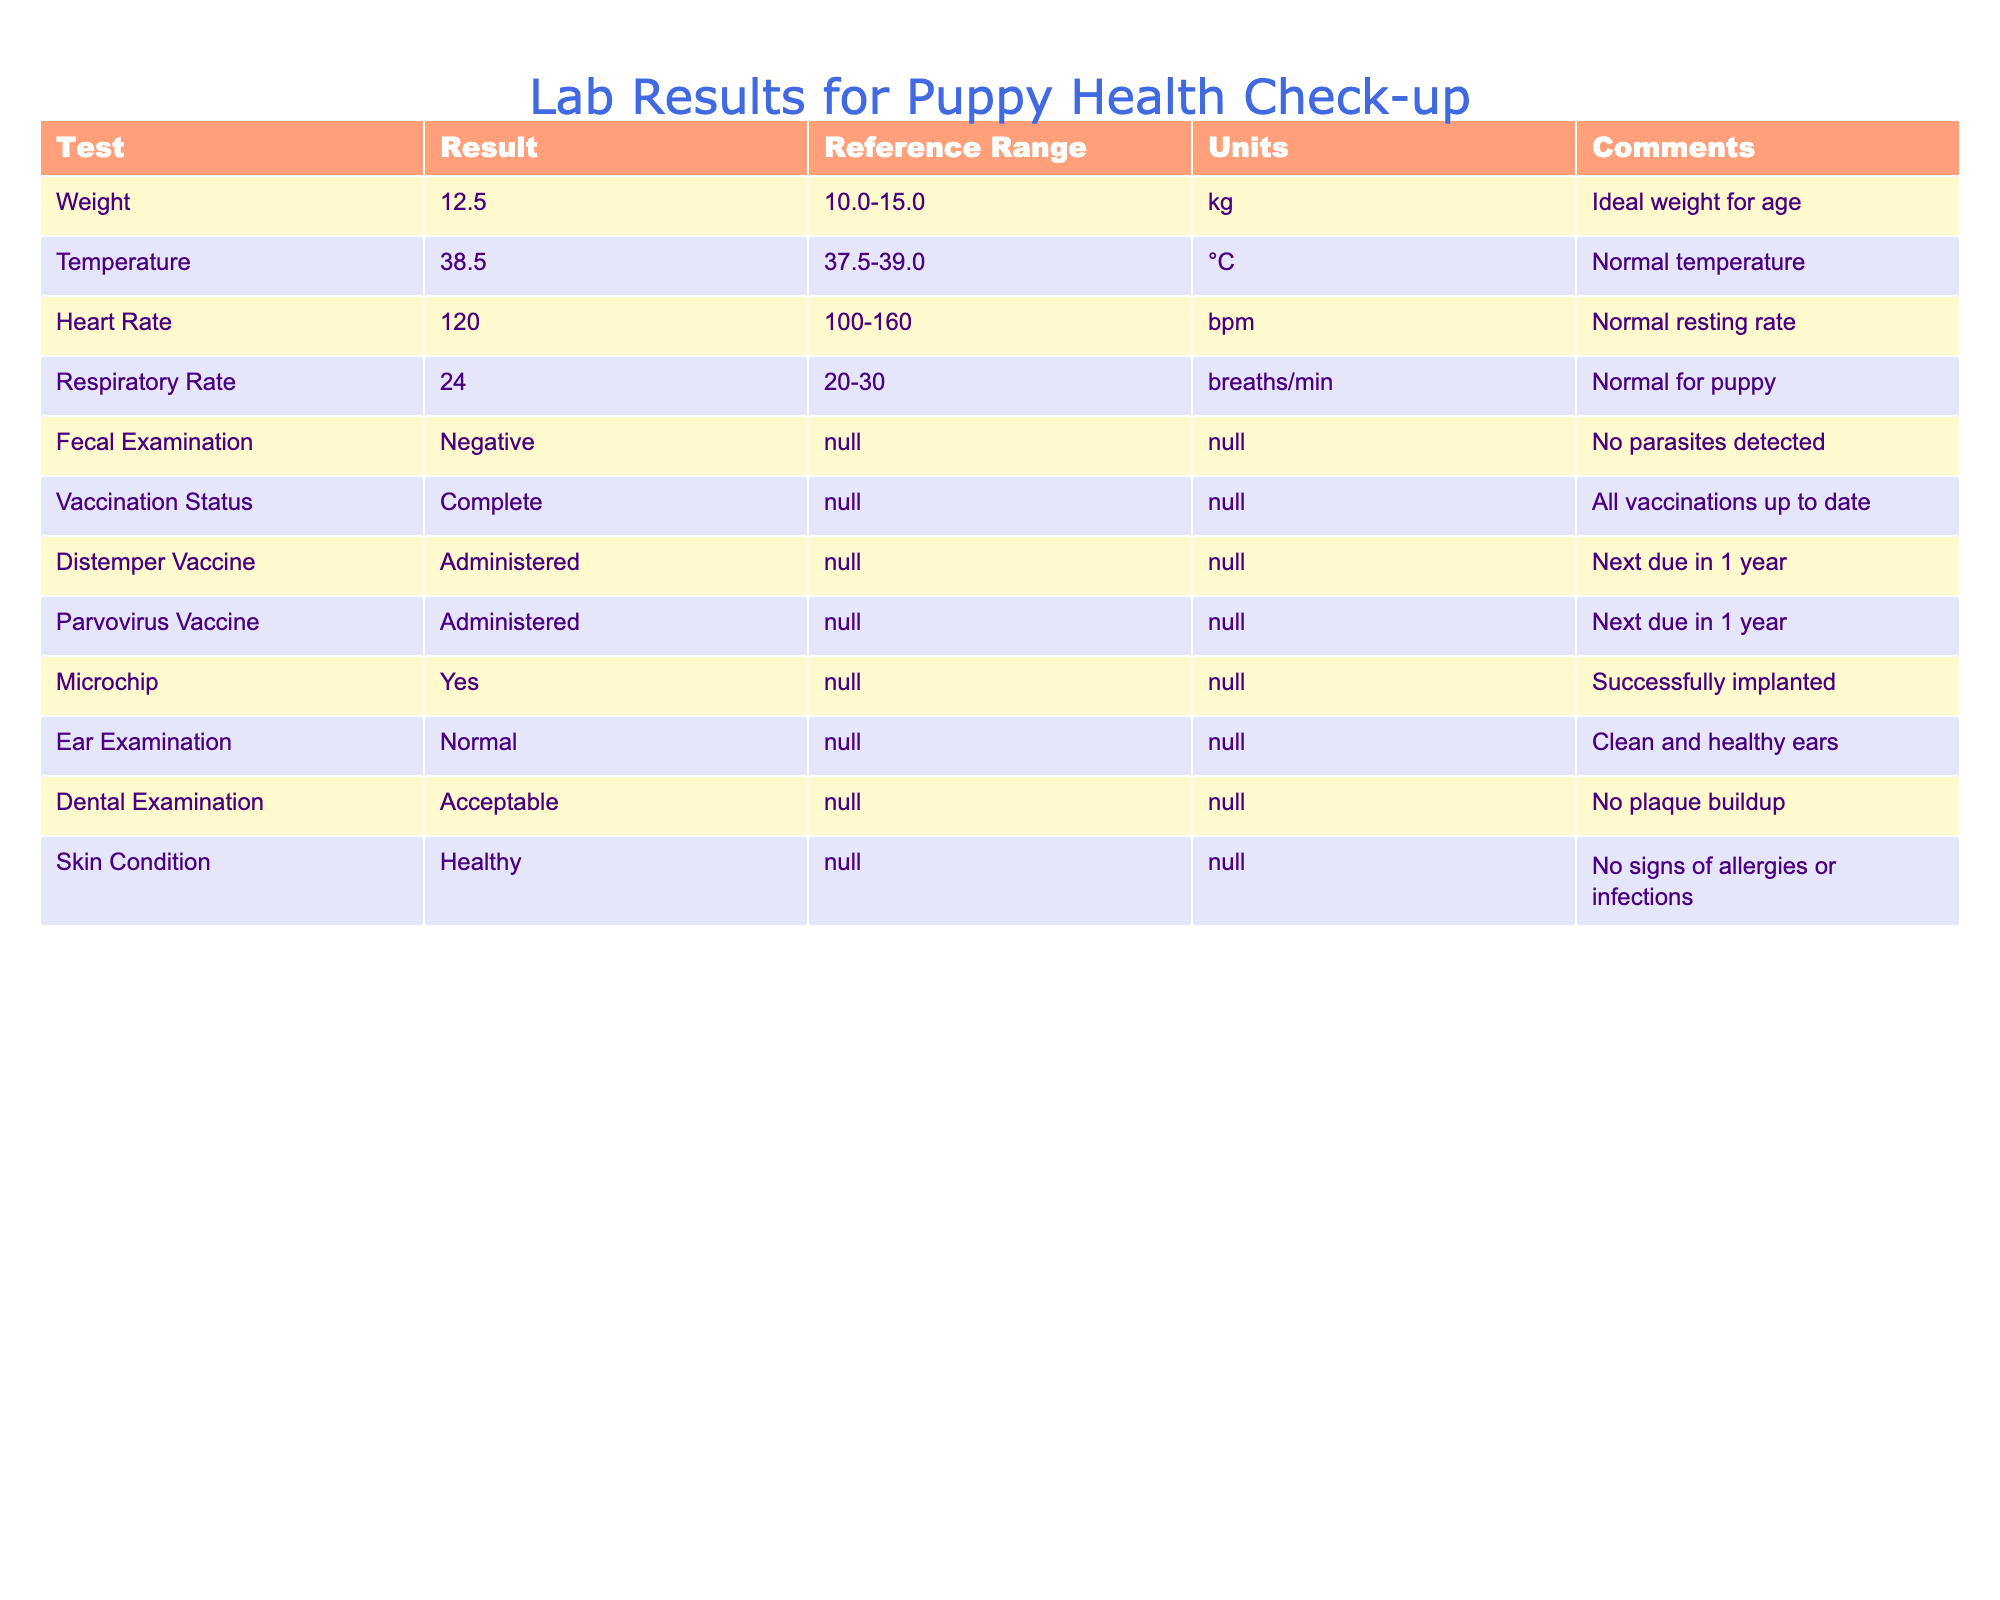What is the puppy's weight? The table lists the "Weight" under the test column, which shows a result of 12.5 kg.
Answer: 12.5 kg Is the puppy's temperature within the normal range? The reference range for temperature is 37.5-39.0 °C, and the puppy's temperature is recorded as 38.5 °C, which is within this range.
Answer: Yes What is the puppy's heart rate? The heart rate is listed under the test column, with a value of 120 bpm.
Answer: 120 bpm How many vaccines has the puppy received? The table contains two rows regarding vaccines: Distemper Vaccine and Parvovirus Vaccine, both of which indicate "Administered." Therefore, the puppy has received a total of two vaccines.
Answer: 2 What is the ideal temperature range for the puppy? The ideal temperature range is provided in the table as 37.5-39.0 °C in the reference range column corresponding to the temperature test.
Answer: 37.5-39.0 °C Is the fecal examination positive or negative? The result of the fecal examination is noted in the table, and it shows "Negative," meaning no parasites were detected.
Answer: Negative Does the puppy have any dental issues? The table mentions the dental examination result as "Acceptable," with a comment indicating no plaque buildup, implying there are no dental issues observed.
Answer: No What is the respiratory rate of the puppy? The respiratory rate is listed in the table as 24 breaths per minute.
Answer: 24 breaths/min What can we infer about the puppy's overall skin condition? The skin condition is described as "Healthy" in the table with no signs of allergies or infections noted, indicating the puppy's skin is in good health.
Answer: Healthy 